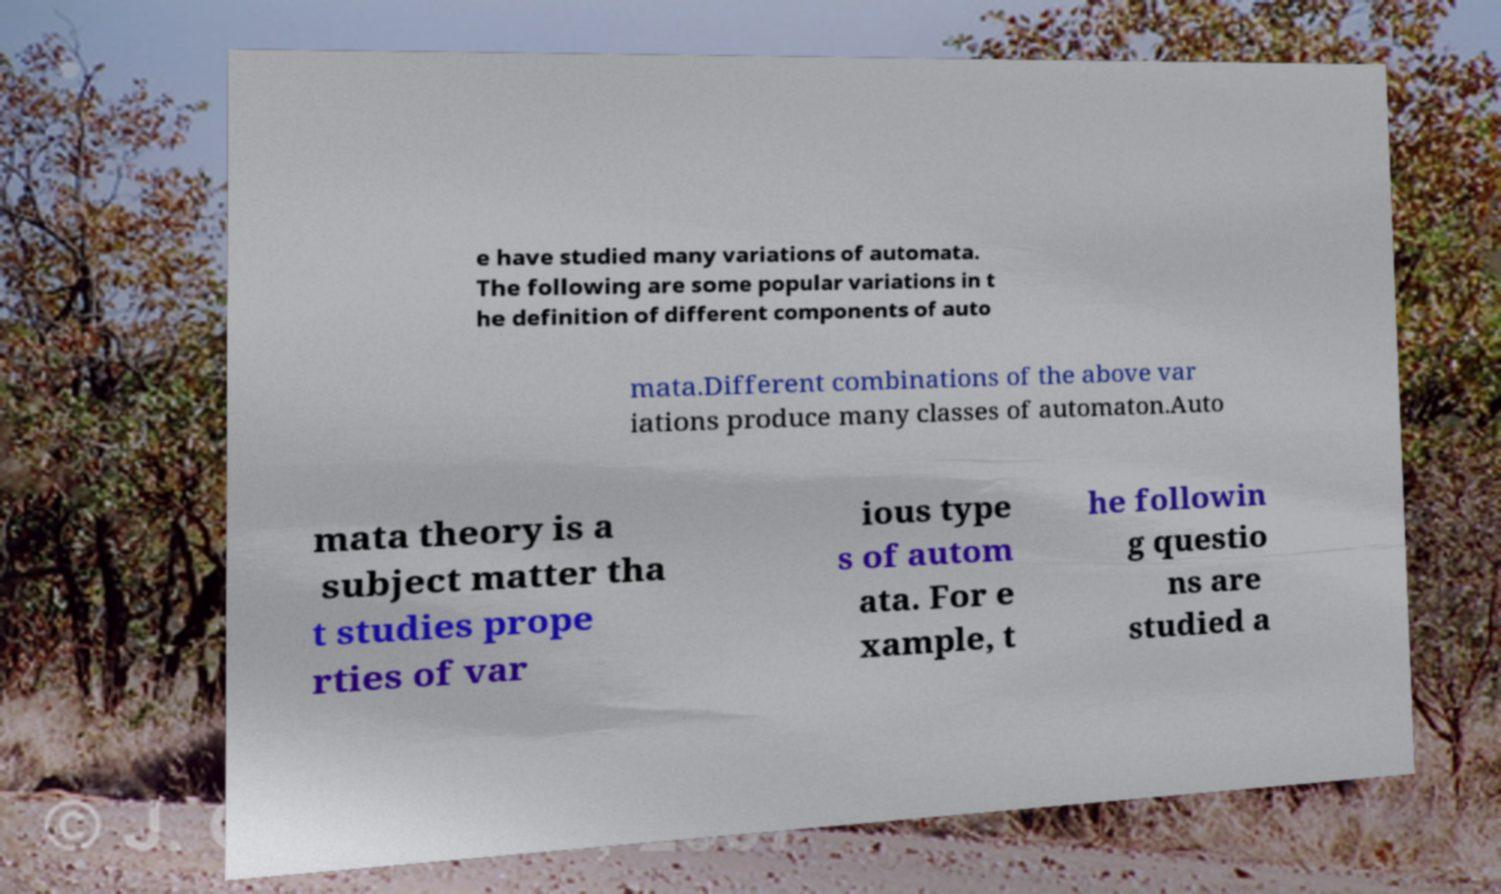Can you read and provide the text displayed in the image?This photo seems to have some interesting text. Can you extract and type it out for me? e have studied many variations of automata. The following are some popular variations in t he definition of different components of auto mata.Different combinations of the above var iations produce many classes of automaton.Auto mata theory is a subject matter tha t studies prope rties of var ious type s of autom ata. For e xample, t he followin g questio ns are studied a 